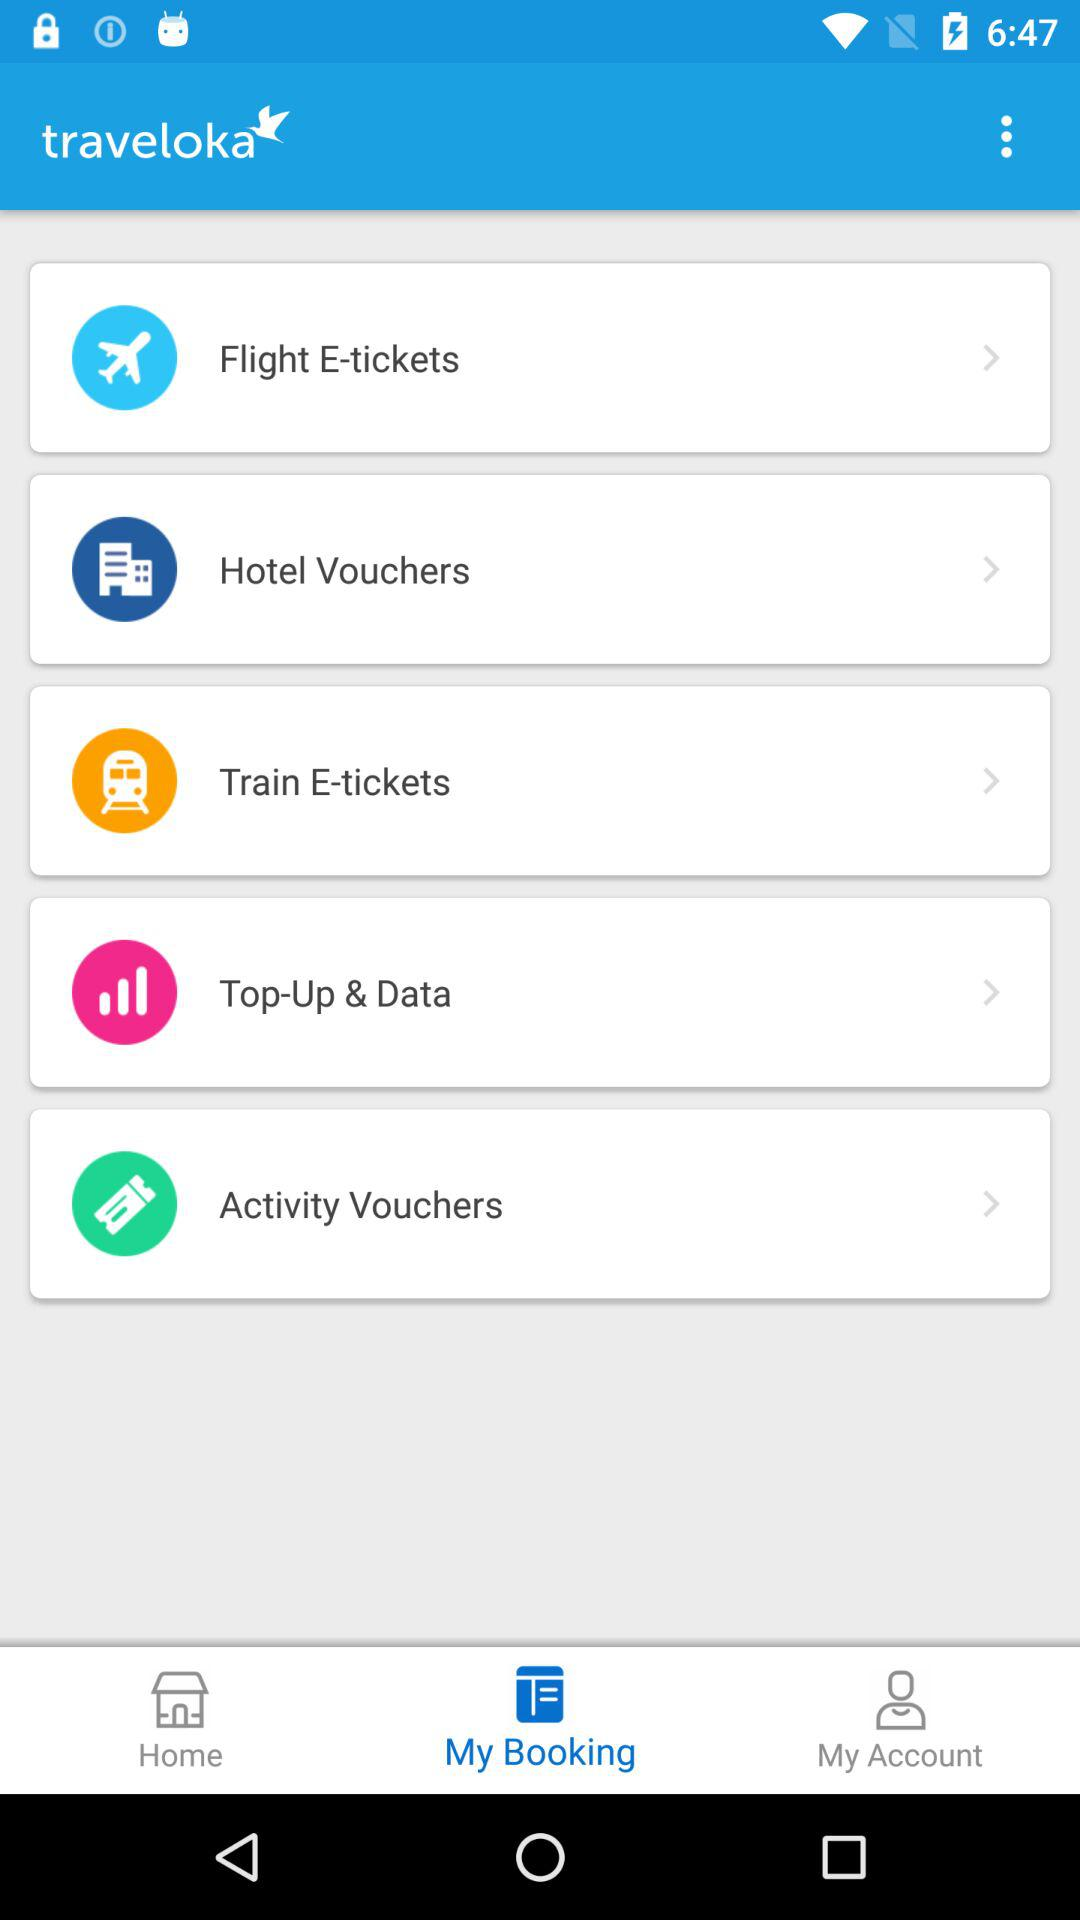What tab has been selected? The tab that has been selected is "My Booking". 